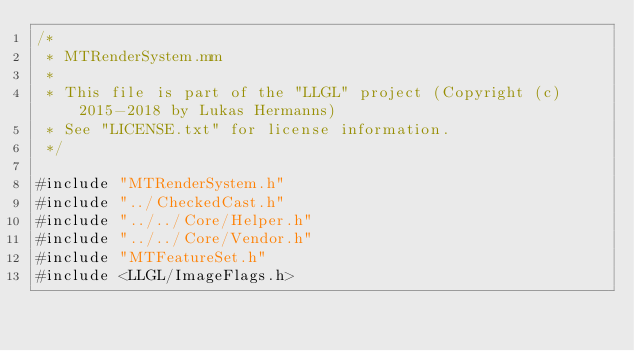Convert code to text. <code><loc_0><loc_0><loc_500><loc_500><_ObjectiveC_>/*
 * MTRenderSystem.mm
 * 
 * This file is part of the "LLGL" project (Copyright (c) 2015-2018 by Lukas Hermanns)
 * See "LICENSE.txt" for license information.
 */

#include "MTRenderSystem.h"
#include "../CheckedCast.h"
#include "../../Core/Helper.h"
#include "../../Core/Vendor.h"
#include "MTFeatureSet.h"
#include <LLGL/ImageFlags.h>

</code> 